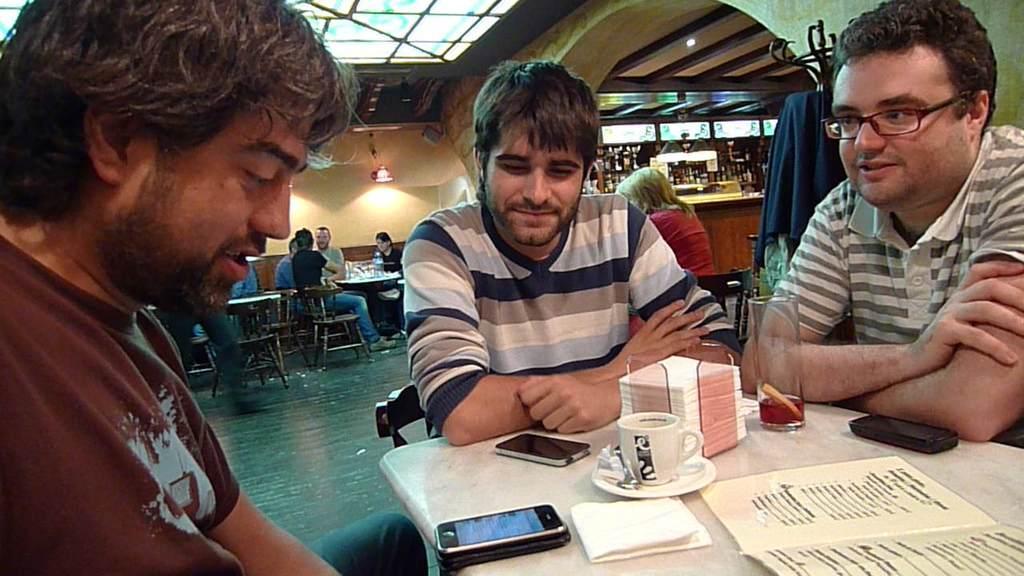In one or two sentences, can you explain what this image depicts? In this picture there are three men sitting on the chair. Iphones, cup, saucer, tissue, glass are seen on the table. There are few people sitting in the background. A light is seen and a green cloth is visible to the right side. 